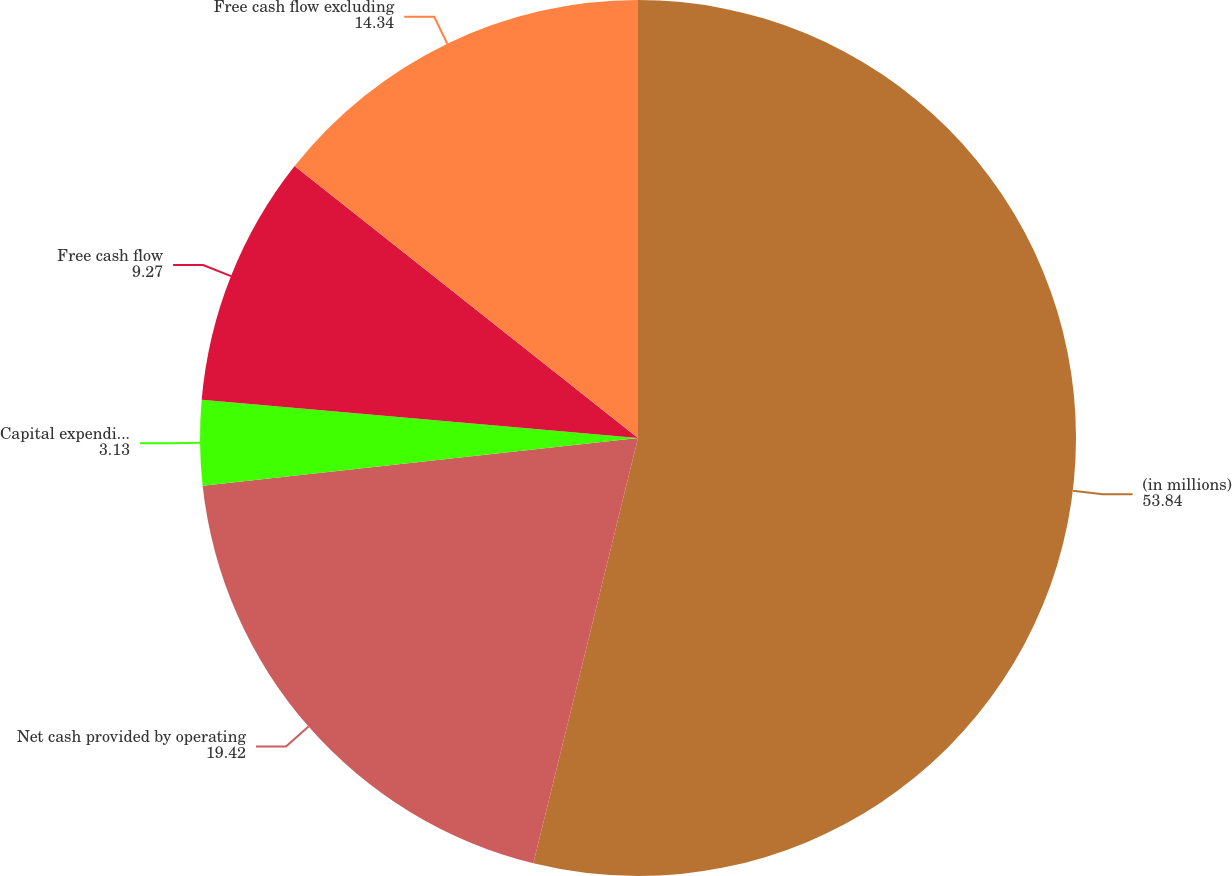Convert chart. <chart><loc_0><loc_0><loc_500><loc_500><pie_chart><fcel>(in millions)<fcel>Net cash provided by operating<fcel>Capital expenditures<fcel>Free cash flow<fcel>Free cash flow excluding<nl><fcel>53.84%<fcel>19.42%<fcel>3.13%<fcel>9.27%<fcel>14.34%<nl></chart> 